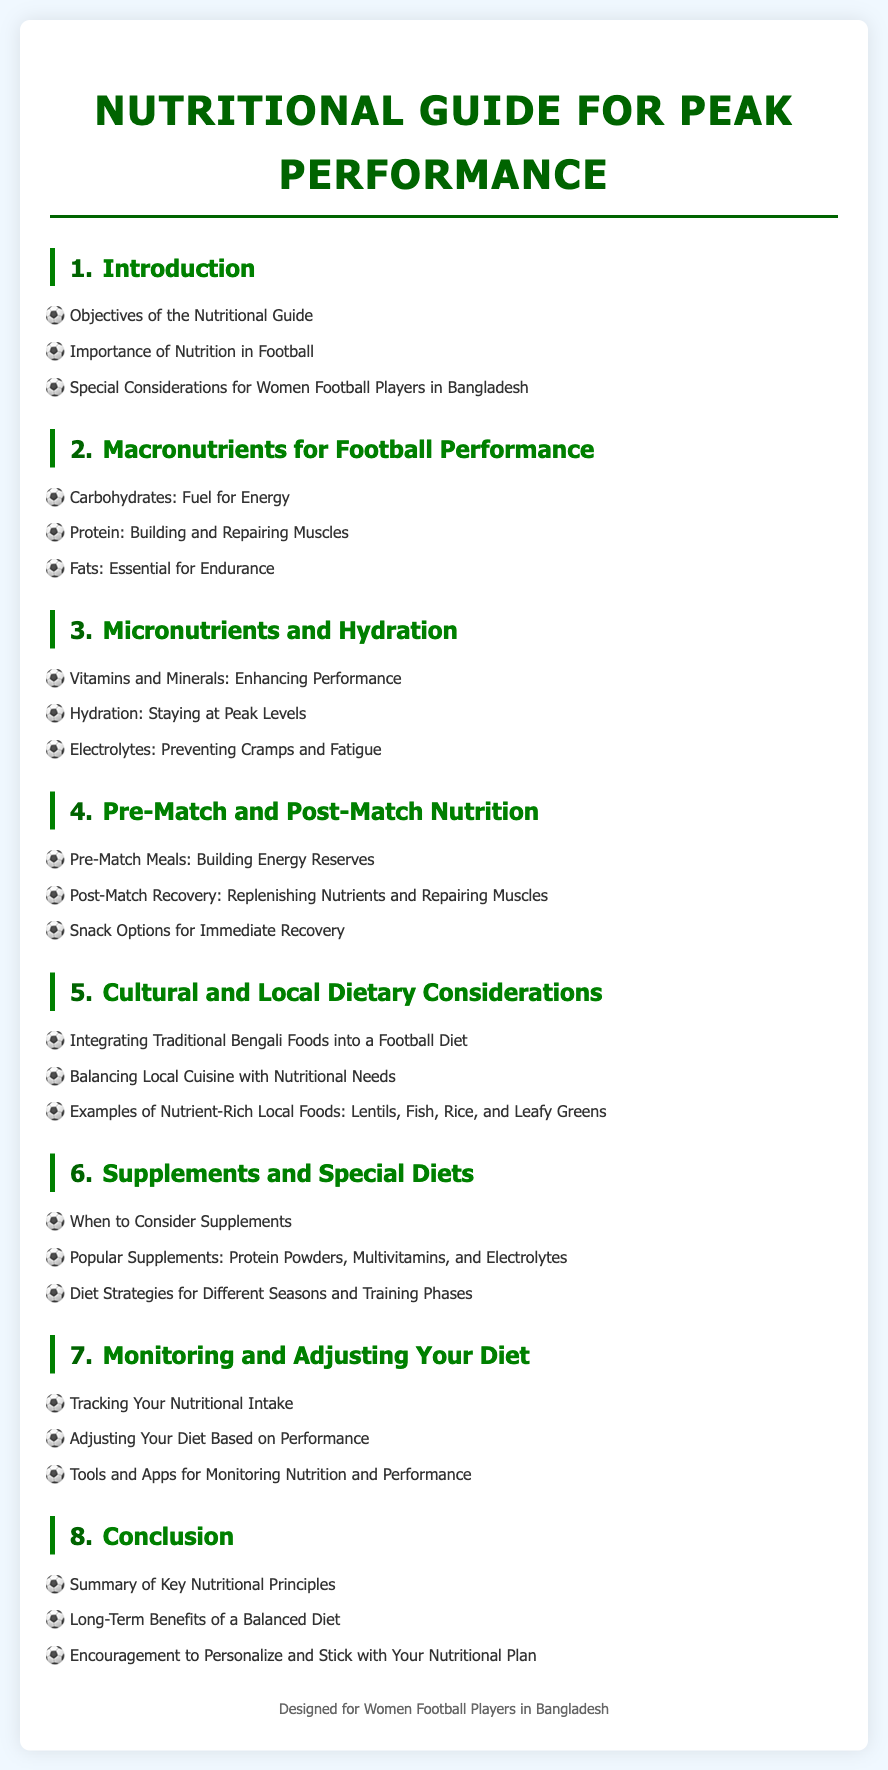what is the title of the document? The title of the document is stated in the main heading at the top, which specifically outlines its purpose.
Answer: Nutritional Guide for Peak Performance how many chapters are there in the guide? The total number of chapters is indicated by the sequential numbering system used in the table of contents.
Answer: 8 which chapter discusses hydration? This chapter is directly referenced under its specific title that focuses on staying optimally hydrated during performance.
Answer: Micronutrients and Hydration what is the main focus of Chapter 5? Chapter 5 highlights the integration of local diets and cuisines to meet nutritional needs for athletes.
Answer: Cultural and Local Dietary Considerations which nutrient is considered fuel for energy? The specific macronutrient addressed in this chapter is recognized for providing energy essential for athletic performance.
Answer: Carbohydrates what type of athletes does the guide primarily cater to? The guide is specifically designed to meet the nutritional needs of a particular group of athletes as mentioned in the footer.
Answer: Women Football Players in Bangladesh what are pre-match meals intended for? The purpose of these meals is articulated in the corresponding section, aimed at enhancing performance before a match.
Answer: Building Energy Reserves which chapter includes tracking your nutritional intake? This topic is covered in a chapter meant for athletes to understand their dietary adjustments based on performance metrics.
Answer: Monitoring and Adjusting Your Diet 